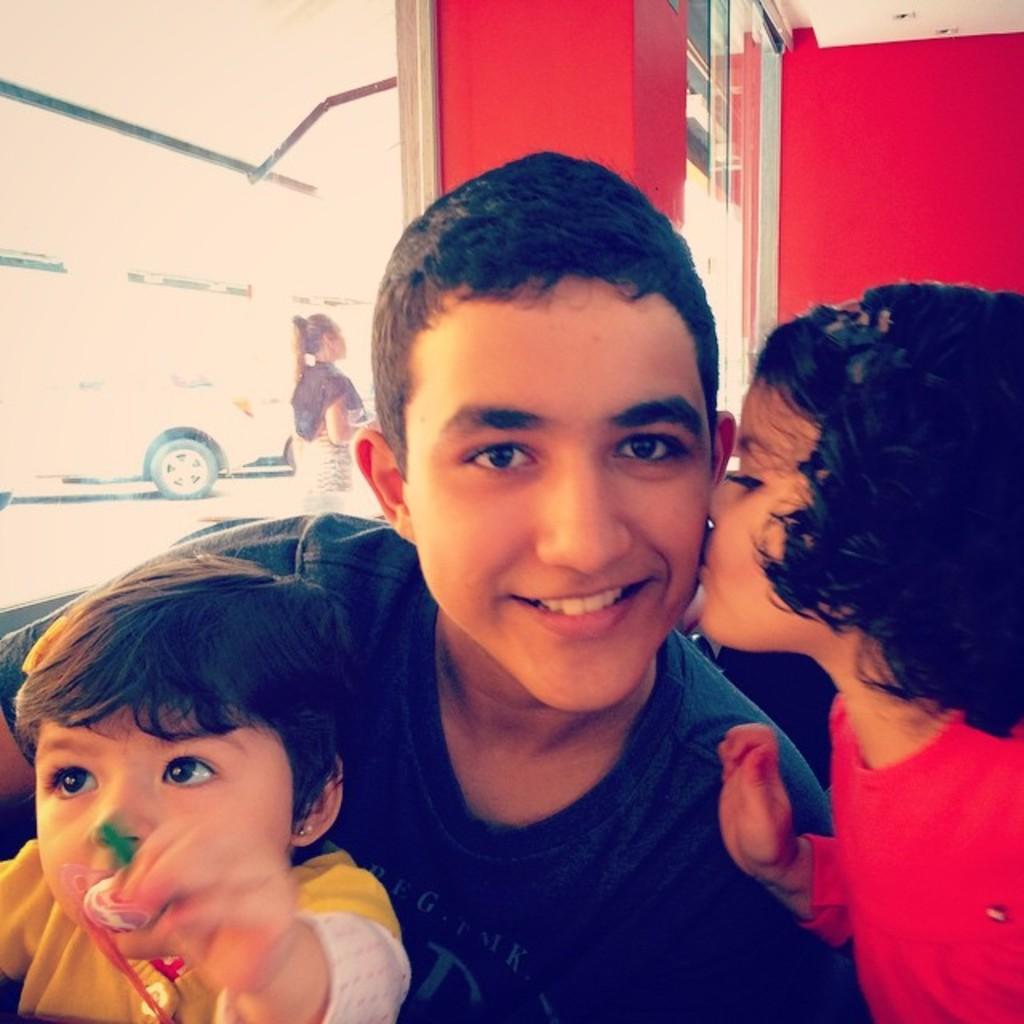Could you give a brief overview of what you see in this image? In this picture there is a boy in the center of the image and there are two children on the right and left side of the image and there is a car and a lady in the background area of the image. 